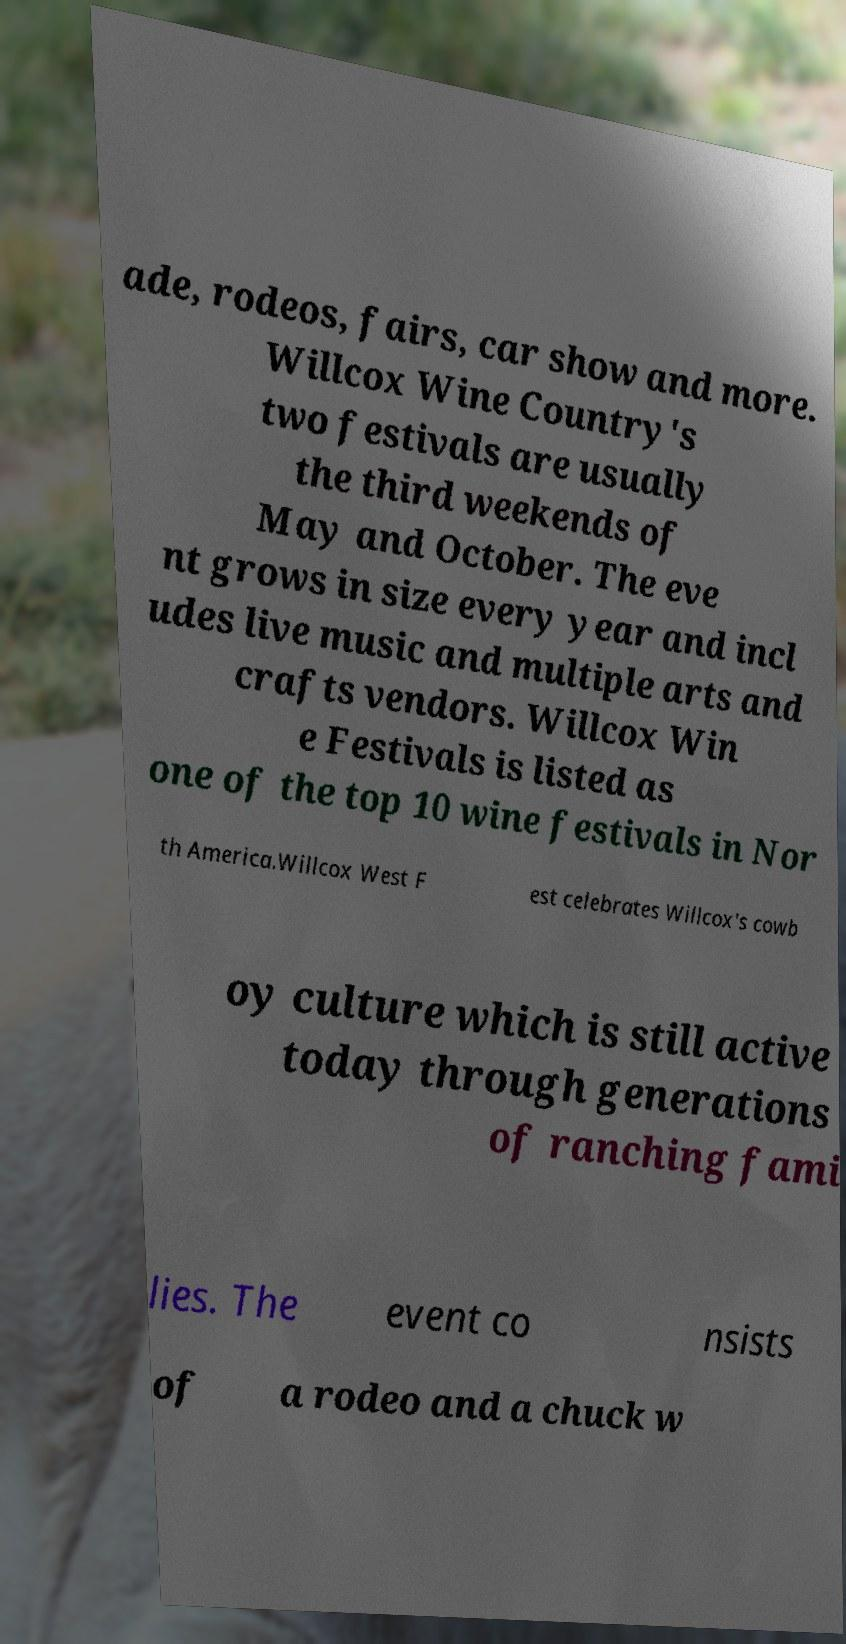What messages or text are displayed in this image? I need them in a readable, typed format. ade, rodeos, fairs, car show and more. Willcox Wine Country's two festivals are usually the third weekends of May and October. The eve nt grows in size every year and incl udes live music and multiple arts and crafts vendors. Willcox Win e Festivals is listed as one of the top 10 wine festivals in Nor th America.Willcox West F est celebrates Willcox's cowb oy culture which is still active today through generations of ranching fami lies. The event co nsists of a rodeo and a chuck w 